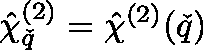<formula> <loc_0><loc_0><loc_500><loc_500>\hat { \chi } _ { \ v q } ^ { ( 2 ) } = \hat { \chi } ^ { ( 2 ) } ( \ v q )</formula> 